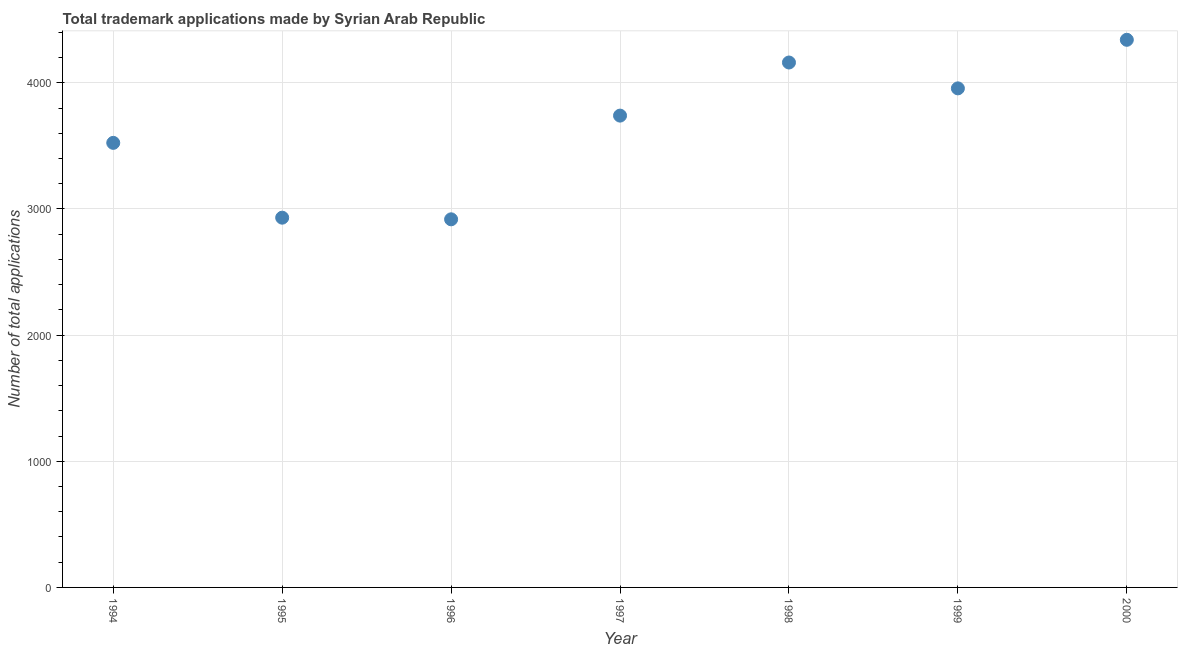What is the number of trademark applications in 1994?
Keep it short and to the point. 3524. Across all years, what is the maximum number of trademark applications?
Ensure brevity in your answer.  4341. Across all years, what is the minimum number of trademark applications?
Offer a very short reply. 2918. What is the sum of the number of trademark applications?
Keep it short and to the point. 2.56e+04. What is the difference between the number of trademark applications in 1997 and 1999?
Make the answer very short. -216. What is the average number of trademark applications per year?
Provide a short and direct response. 3653. What is the median number of trademark applications?
Your answer should be very brief. 3740. What is the ratio of the number of trademark applications in 1995 to that in 1999?
Give a very brief answer. 0.74. What is the difference between the highest and the second highest number of trademark applications?
Your answer should be very brief. 180. What is the difference between the highest and the lowest number of trademark applications?
Offer a terse response. 1423. In how many years, is the number of trademark applications greater than the average number of trademark applications taken over all years?
Your answer should be compact. 4. How many dotlines are there?
Offer a terse response. 1. How many years are there in the graph?
Make the answer very short. 7. What is the difference between two consecutive major ticks on the Y-axis?
Your answer should be very brief. 1000. Are the values on the major ticks of Y-axis written in scientific E-notation?
Your response must be concise. No. Does the graph contain any zero values?
Offer a very short reply. No. Does the graph contain grids?
Provide a succinct answer. Yes. What is the title of the graph?
Give a very brief answer. Total trademark applications made by Syrian Arab Republic. What is the label or title of the Y-axis?
Provide a short and direct response. Number of total applications. What is the Number of total applications in 1994?
Your answer should be compact. 3524. What is the Number of total applications in 1995?
Offer a very short reply. 2931. What is the Number of total applications in 1996?
Offer a very short reply. 2918. What is the Number of total applications in 1997?
Give a very brief answer. 3740. What is the Number of total applications in 1998?
Give a very brief answer. 4161. What is the Number of total applications in 1999?
Your response must be concise. 3956. What is the Number of total applications in 2000?
Offer a very short reply. 4341. What is the difference between the Number of total applications in 1994 and 1995?
Offer a very short reply. 593. What is the difference between the Number of total applications in 1994 and 1996?
Your response must be concise. 606. What is the difference between the Number of total applications in 1994 and 1997?
Offer a very short reply. -216. What is the difference between the Number of total applications in 1994 and 1998?
Offer a terse response. -637. What is the difference between the Number of total applications in 1994 and 1999?
Your answer should be very brief. -432. What is the difference between the Number of total applications in 1994 and 2000?
Your answer should be compact. -817. What is the difference between the Number of total applications in 1995 and 1996?
Your answer should be compact. 13. What is the difference between the Number of total applications in 1995 and 1997?
Keep it short and to the point. -809. What is the difference between the Number of total applications in 1995 and 1998?
Offer a very short reply. -1230. What is the difference between the Number of total applications in 1995 and 1999?
Provide a succinct answer. -1025. What is the difference between the Number of total applications in 1995 and 2000?
Your response must be concise. -1410. What is the difference between the Number of total applications in 1996 and 1997?
Give a very brief answer. -822. What is the difference between the Number of total applications in 1996 and 1998?
Offer a very short reply. -1243. What is the difference between the Number of total applications in 1996 and 1999?
Provide a succinct answer. -1038. What is the difference between the Number of total applications in 1996 and 2000?
Keep it short and to the point. -1423. What is the difference between the Number of total applications in 1997 and 1998?
Provide a short and direct response. -421. What is the difference between the Number of total applications in 1997 and 1999?
Your response must be concise. -216. What is the difference between the Number of total applications in 1997 and 2000?
Your answer should be very brief. -601. What is the difference between the Number of total applications in 1998 and 1999?
Offer a very short reply. 205. What is the difference between the Number of total applications in 1998 and 2000?
Provide a short and direct response. -180. What is the difference between the Number of total applications in 1999 and 2000?
Your answer should be very brief. -385. What is the ratio of the Number of total applications in 1994 to that in 1995?
Give a very brief answer. 1.2. What is the ratio of the Number of total applications in 1994 to that in 1996?
Keep it short and to the point. 1.21. What is the ratio of the Number of total applications in 1994 to that in 1997?
Offer a very short reply. 0.94. What is the ratio of the Number of total applications in 1994 to that in 1998?
Your answer should be compact. 0.85. What is the ratio of the Number of total applications in 1994 to that in 1999?
Offer a very short reply. 0.89. What is the ratio of the Number of total applications in 1994 to that in 2000?
Keep it short and to the point. 0.81. What is the ratio of the Number of total applications in 1995 to that in 1997?
Offer a very short reply. 0.78. What is the ratio of the Number of total applications in 1995 to that in 1998?
Give a very brief answer. 0.7. What is the ratio of the Number of total applications in 1995 to that in 1999?
Offer a terse response. 0.74. What is the ratio of the Number of total applications in 1995 to that in 2000?
Your answer should be very brief. 0.68. What is the ratio of the Number of total applications in 1996 to that in 1997?
Give a very brief answer. 0.78. What is the ratio of the Number of total applications in 1996 to that in 1998?
Offer a very short reply. 0.7. What is the ratio of the Number of total applications in 1996 to that in 1999?
Provide a succinct answer. 0.74. What is the ratio of the Number of total applications in 1996 to that in 2000?
Keep it short and to the point. 0.67. What is the ratio of the Number of total applications in 1997 to that in 1998?
Provide a short and direct response. 0.9. What is the ratio of the Number of total applications in 1997 to that in 1999?
Your response must be concise. 0.94. What is the ratio of the Number of total applications in 1997 to that in 2000?
Your answer should be compact. 0.86. What is the ratio of the Number of total applications in 1998 to that in 1999?
Provide a short and direct response. 1.05. What is the ratio of the Number of total applications in 1999 to that in 2000?
Make the answer very short. 0.91. 